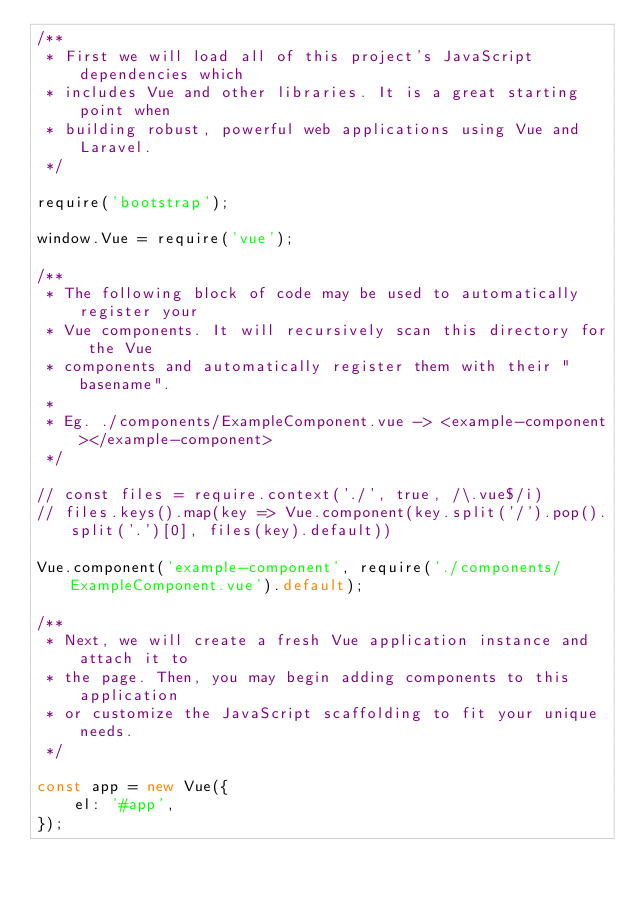<code> <loc_0><loc_0><loc_500><loc_500><_JavaScript_>/**
 * First we will load all of this project's JavaScript dependencies which
 * includes Vue and other libraries. It is a great starting point when
 * building robust, powerful web applications using Vue and Laravel.
 */

require('bootstrap');

window.Vue = require('vue');

/**
 * The following block of code may be used to automatically register your
 * Vue components. It will recursively scan this directory for the Vue
 * components and automatically register them with their "basename".
 *
 * Eg. ./components/ExampleComponent.vue -> <example-component></example-component>
 */

// const files = require.context('./', true, /\.vue$/i)
// files.keys().map(key => Vue.component(key.split('/').pop().split('.')[0], files(key).default))

Vue.component('example-component', require('./components/ExampleComponent.vue').default);

/**
 * Next, we will create a fresh Vue application instance and attach it to
 * the page. Then, you may begin adding components to this application
 * or customize the JavaScript scaffolding to fit your unique needs.
 */

const app = new Vue({
    el: '#app',
});
</code> 